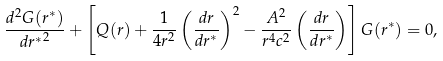Convert formula to latex. <formula><loc_0><loc_0><loc_500><loc_500>\frac { d ^ { 2 } G ( r ^ { * } ) } { d { r ^ { * } } ^ { 2 } } + \left [ Q ( r ) + \frac { 1 } { 4 r ^ { 2 } } \left ( \frac { d r } { d r ^ { * } } \right ) ^ { 2 } - \frac { A ^ { 2 } } { r ^ { 4 } c ^ { 2 } } \left ( \frac { d r } { d r ^ { * } } \right ) \right ] G ( r ^ { * } ) = 0 ,</formula> 